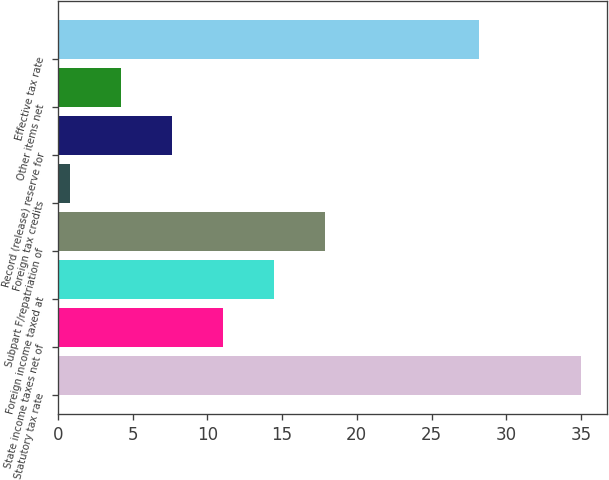<chart> <loc_0><loc_0><loc_500><loc_500><bar_chart><fcel>Statutory tax rate<fcel>State income taxes net of<fcel>Foreign income taxed at<fcel>Subpart F/repatriation of<fcel>Foreign tax credits<fcel>Record (release) reserve for<fcel>Other items net<fcel>Effective tax rate<nl><fcel>35<fcel>11.06<fcel>14.48<fcel>17.9<fcel>0.8<fcel>7.64<fcel>4.22<fcel>28.2<nl></chart> 